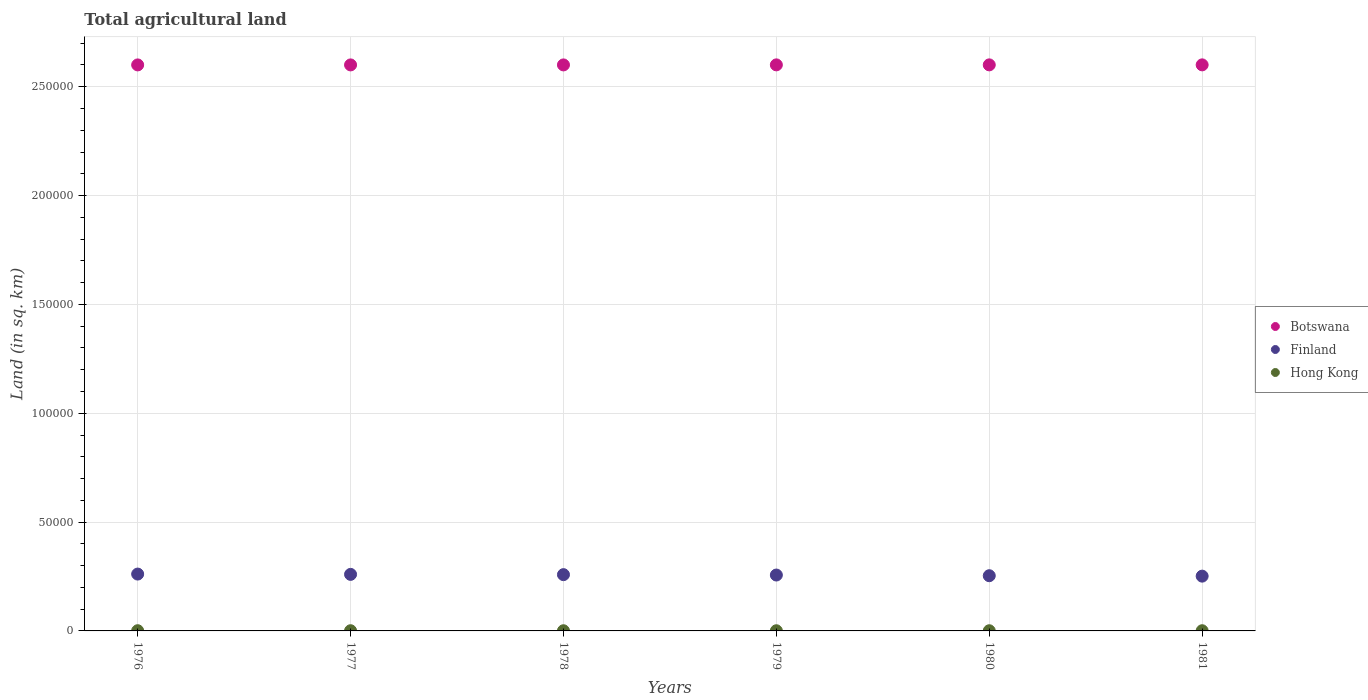How many different coloured dotlines are there?
Offer a terse response. 3. Is the number of dotlines equal to the number of legend labels?
Your answer should be compact. Yes. What is the total agricultural land in Botswana in 1978?
Provide a short and direct response. 2.60e+05. Across all years, what is the maximum total agricultural land in Botswana?
Your answer should be compact. 2.60e+05. Across all years, what is the minimum total agricultural land in Finland?
Your answer should be very brief. 2.52e+04. In which year was the total agricultural land in Hong Kong maximum?
Give a very brief answer. 1976. In which year was the total agricultural land in Hong Kong minimum?
Your answer should be very brief. 1978. What is the total total agricultural land in Finland in the graph?
Your answer should be very brief. 1.54e+05. What is the difference between the total agricultural land in Botswana in 1976 and that in 1979?
Offer a terse response. -20. What is the difference between the total agricultural land in Hong Kong in 1978 and the total agricultural land in Finland in 1980?
Offer a very short reply. -2.53e+04. What is the average total agricultural land in Finland per year?
Your response must be concise. 2.57e+04. In the year 1980, what is the difference between the total agricultural land in Finland and total agricultural land in Botswana?
Your response must be concise. -2.35e+05. What is the ratio of the total agricultural land in Finland in 1976 to that in 1981?
Your response must be concise. 1.04. Is the difference between the total agricultural land in Finland in 1980 and 1981 greater than the difference between the total agricultural land in Botswana in 1980 and 1981?
Offer a terse response. Yes. What is the difference between the highest and the second highest total agricultural land in Hong Kong?
Ensure brevity in your answer.  10. What is the difference between the highest and the lowest total agricultural land in Finland?
Give a very brief answer. 952. In how many years, is the total agricultural land in Botswana greater than the average total agricultural land in Botswana taken over all years?
Provide a succinct answer. 3. Does the total agricultural land in Hong Kong monotonically increase over the years?
Your answer should be compact. No. What is the difference between two consecutive major ticks on the Y-axis?
Ensure brevity in your answer.  5.00e+04. Does the graph contain any zero values?
Your response must be concise. No. Where does the legend appear in the graph?
Your answer should be compact. Center right. What is the title of the graph?
Make the answer very short. Total agricultural land. What is the label or title of the X-axis?
Give a very brief answer. Years. What is the label or title of the Y-axis?
Make the answer very short. Land (in sq. km). What is the Land (in sq. km) of Botswana in 1976?
Make the answer very short. 2.60e+05. What is the Land (in sq. km) of Finland in 1976?
Provide a short and direct response. 2.61e+04. What is the Land (in sq. km) in Hong Kong in 1976?
Your answer should be very brief. 100. What is the Land (in sq. km) of Botswana in 1977?
Provide a short and direct response. 2.60e+05. What is the Land (in sq. km) of Finland in 1977?
Offer a terse response. 2.60e+04. What is the Land (in sq. km) in Botswana in 1978?
Provide a short and direct response. 2.60e+05. What is the Land (in sq. km) in Finland in 1978?
Your answer should be compact. 2.59e+04. What is the Land (in sq. km) in Hong Kong in 1978?
Provide a succinct answer. 80. What is the Land (in sq. km) of Botswana in 1979?
Give a very brief answer. 2.60e+05. What is the Land (in sq. km) of Finland in 1979?
Keep it short and to the point. 2.57e+04. What is the Land (in sq. km) of Botswana in 1980?
Your answer should be very brief. 2.60e+05. What is the Land (in sq. km) in Finland in 1980?
Your answer should be compact. 2.54e+04. What is the Land (in sq. km) of Hong Kong in 1980?
Offer a very short reply. 80. What is the Land (in sq. km) in Botswana in 1981?
Give a very brief answer. 2.60e+05. What is the Land (in sq. km) in Finland in 1981?
Give a very brief answer. 2.52e+04. What is the Land (in sq. km) of Hong Kong in 1981?
Offer a very short reply. 90. Across all years, what is the maximum Land (in sq. km) in Botswana?
Give a very brief answer. 2.60e+05. Across all years, what is the maximum Land (in sq. km) of Finland?
Your response must be concise. 2.61e+04. Across all years, what is the maximum Land (in sq. km) in Hong Kong?
Your response must be concise. 100. Across all years, what is the minimum Land (in sq. km) of Botswana?
Ensure brevity in your answer.  2.60e+05. Across all years, what is the minimum Land (in sq. km) of Finland?
Keep it short and to the point. 2.52e+04. Across all years, what is the minimum Land (in sq. km) of Hong Kong?
Keep it short and to the point. 80. What is the total Land (in sq. km) in Botswana in the graph?
Offer a terse response. 1.56e+06. What is the total Land (in sq. km) of Finland in the graph?
Make the answer very short. 1.54e+05. What is the total Land (in sq. km) in Hong Kong in the graph?
Your answer should be compact. 520. What is the difference between the Land (in sq. km) of Finland in 1976 and that in 1977?
Ensure brevity in your answer.  143. What is the difference between the Land (in sq. km) of Hong Kong in 1976 and that in 1977?
Make the answer very short. 10. What is the difference between the Land (in sq. km) in Finland in 1976 and that in 1978?
Provide a short and direct response. 268. What is the difference between the Land (in sq. km) of Hong Kong in 1976 and that in 1978?
Your answer should be very brief. 20. What is the difference between the Land (in sq. km) of Finland in 1976 and that in 1979?
Ensure brevity in your answer.  444. What is the difference between the Land (in sq. km) of Finland in 1976 and that in 1980?
Your answer should be very brief. 759. What is the difference between the Land (in sq. km) of Finland in 1976 and that in 1981?
Give a very brief answer. 952. What is the difference between the Land (in sq. km) of Finland in 1977 and that in 1978?
Make the answer very short. 125. What is the difference between the Land (in sq. km) of Hong Kong in 1977 and that in 1978?
Your response must be concise. 10. What is the difference between the Land (in sq. km) of Botswana in 1977 and that in 1979?
Your response must be concise. -20. What is the difference between the Land (in sq. km) of Finland in 1977 and that in 1979?
Offer a very short reply. 301. What is the difference between the Land (in sq. km) of Botswana in 1977 and that in 1980?
Keep it short and to the point. -20. What is the difference between the Land (in sq. km) of Finland in 1977 and that in 1980?
Your response must be concise. 616. What is the difference between the Land (in sq. km) in Botswana in 1977 and that in 1981?
Give a very brief answer. -20. What is the difference between the Land (in sq. km) in Finland in 1977 and that in 1981?
Offer a very short reply. 809. What is the difference between the Land (in sq. km) in Hong Kong in 1977 and that in 1981?
Offer a terse response. 0. What is the difference between the Land (in sq. km) of Finland in 1978 and that in 1979?
Provide a succinct answer. 176. What is the difference between the Land (in sq. km) in Botswana in 1978 and that in 1980?
Offer a terse response. -20. What is the difference between the Land (in sq. km) in Finland in 1978 and that in 1980?
Your answer should be compact. 491. What is the difference between the Land (in sq. km) in Finland in 1978 and that in 1981?
Your response must be concise. 684. What is the difference between the Land (in sq. km) of Hong Kong in 1978 and that in 1981?
Give a very brief answer. -10. What is the difference between the Land (in sq. km) in Botswana in 1979 and that in 1980?
Provide a short and direct response. 0. What is the difference between the Land (in sq. km) of Finland in 1979 and that in 1980?
Your response must be concise. 315. What is the difference between the Land (in sq. km) of Botswana in 1979 and that in 1981?
Keep it short and to the point. 0. What is the difference between the Land (in sq. km) of Finland in 1979 and that in 1981?
Give a very brief answer. 508. What is the difference between the Land (in sq. km) in Botswana in 1980 and that in 1981?
Offer a terse response. 0. What is the difference between the Land (in sq. km) of Finland in 1980 and that in 1981?
Offer a very short reply. 193. What is the difference between the Land (in sq. km) in Botswana in 1976 and the Land (in sq. km) in Finland in 1977?
Offer a very short reply. 2.34e+05. What is the difference between the Land (in sq. km) in Botswana in 1976 and the Land (in sq. km) in Hong Kong in 1977?
Make the answer very short. 2.60e+05. What is the difference between the Land (in sq. km) of Finland in 1976 and the Land (in sq. km) of Hong Kong in 1977?
Provide a short and direct response. 2.60e+04. What is the difference between the Land (in sq. km) of Botswana in 1976 and the Land (in sq. km) of Finland in 1978?
Offer a very short reply. 2.34e+05. What is the difference between the Land (in sq. km) of Botswana in 1976 and the Land (in sq. km) of Hong Kong in 1978?
Give a very brief answer. 2.60e+05. What is the difference between the Land (in sq. km) of Finland in 1976 and the Land (in sq. km) of Hong Kong in 1978?
Your answer should be compact. 2.60e+04. What is the difference between the Land (in sq. km) in Botswana in 1976 and the Land (in sq. km) in Finland in 1979?
Your answer should be very brief. 2.34e+05. What is the difference between the Land (in sq. km) of Botswana in 1976 and the Land (in sq. km) of Hong Kong in 1979?
Ensure brevity in your answer.  2.60e+05. What is the difference between the Land (in sq. km) of Finland in 1976 and the Land (in sq. km) of Hong Kong in 1979?
Your answer should be very brief. 2.60e+04. What is the difference between the Land (in sq. km) in Botswana in 1976 and the Land (in sq. km) in Finland in 1980?
Make the answer very short. 2.35e+05. What is the difference between the Land (in sq. km) in Botswana in 1976 and the Land (in sq. km) in Hong Kong in 1980?
Give a very brief answer. 2.60e+05. What is the difference between the Land (in sq. km) in Finland in 1976 and the Land (in sq. km) in Hong Kong in 1980?
Your answer should be very brief. 2.60e+04. What is the difference between the Land (in sq. km) of Botswana in 1976 and the Land (in sq. km) of Finland in 1981?
Provide a succinct answer. 2.35e+05. What is the difference between the Land (in sq. km) of Botswana in 1976 and the Land (in sq. km) of Hong Kong in 1981?
Your answer should be compact. 2.60e+05. What is the difference between the Land (in sq. km) in Finland in 1976 and the Land (in sq. km) in Hong Kong in 1981?
Your answer should be compact. 2.60e+04. What is the difference between the Land (in sq. km) in Botswana in 1977 and the Land (in sq. km) in Finland in 1978?
Offer a terse response. 2.34e+05. What is the difference between the Land (in sq. km) in Botswana in 1977 and the Land (in sq. km) in Hong Kong in 1978?
Your answer should be very brief. 2.60e+05. What is the difference between the Land (in sq. km) of Finland in 1977 and the Land (in sq. km) of Hong Kong in 1978?
Offer a terse response. 2.59e+04. What is the difference between the Land (in sq. km) of Botswana in 1977 and the Land (in sq. km) of Finland in 1979?
Provide a short and direct response. 2.34e+05. What is the difference between the Land (in sq. km) in Botswana in 1977 and the Land (in sq. km) in Hong Kong in 1979?
Your answer should be very brief. 2.60e+05. What is the difference between the Land (in sq. km) in Finland in 1977 and the Land (in sq. km) in Hong Kong in 1979?
Provide a succinct answer. 2.59e+04. What is the difference between the Land (in sq. km) of Botswana in 1977 and the Land (in sq. km) of Finland in 1980?
Ensure brevity in your answer.  2.35e+05. What is the difference between the Land (in sq. km) in Botswana in 1977 and the Land (in sq. km) in Hong Kong in 1980?
Offer a very short reply. 2.60e+05. What is the difference between the Land (in sq. km) in Finland in 1977 and the Land (in sq. km) in Hong Kong in 1980?
Give a very brief answer. 2.59e+04. What is the difference between the Land (in sq. km) of Botswana in 1977 and the Land (in sq. km) of Finland in 1981?
Your response must be concise. 2.35e+05. What is the difference between the Land (in sq. km) of Botswana in 1977 and the Land (in sq. km) of Hong Kong in 1981?
Give a very brief answer. 2.60e+05. What is the difference between the Land (in sq. km) of Finland in 1977 and the Land (in sq. km) of Hong Kong in 1981?
Provide a succinct answer. 2.59e+04. What is the difference between the Land (in sq. km) of Botswana in 1978 and the Land (in sq. km) of Finland in 1979?
Keep it short and to the point. 2.34e+05. What is the difference between the Land (in sq. km) of Botswana in 1978 and the Land (in sq. km) of Hong Kong in 1979?
Make the answer very short. 2.60e+05. What is the difference between the Land (in sq. km) of Finland in 1978 and the Land (in sq. km) of Hong Kong in 1979?
Provide a short and direct response. 2.58e+04. What is the difference between the Land (in sq. km) of Botswana in 1978 and the Land (in sq. km) of Finland in 1980?
Offer a very short reply. 2.35e+05. What is the difference between the Land (in sq. km) in Botswana in 1978 and the Land (in sq. km) in Hong Kong in 1980?
Provide a short and direct response. 2.60e+05. What is the difference between the Land (in sq. km) of Finland in 1978 and the Land (in sq. km) of Hong Kong in 1980?
Provide a short and direct response. 2.58e+04. What is the difference between the Land (in sq. km) in Botswana in 1978 and the Land (in sq. km) in Finland in 1981?
Make the answer very short. 2.35e+05. What is the difference between the Land (in sq. km) of Botswana in 1978 and the Land (in sq. km) of Hong Kong in 1981?
Provide a succinct answer. 2.60e+05. What is the difference between the Land (in sq. km) of Finland in 1978 and the Land (in sq. km) of Hong Kong in 1981?
Your answer should be very brief. 2.58e+04. What is the difference between the Land (in sq. km) in Botswana in 1979 and the Land (in sq. km) in Finland in 1980?
Provide a succinct answer. 2.35e+05. What is the difference between the Land (in sq. km) of Botswana in 1979 and the Land (in sq. km) of Hong Kong in 1980?
Give a very brief answer. 2.60e+05. What is the difference between the Land (in sq. km) in Finland in 1979 and the Land (in sq. km) in Hong Kong in 1980?
Make the answer very short. 2.56e+04. What is the difference between the Land (in sq. km) of Botswana in 1979 and the Land (in sq. km) of Finland in 1981?
Your response must be concise. 2.35e+05. What is the difference between the Land (in sq. km) in Botswana in 1979 and the Land (in sq. km) in Hong Kong in 1981?
Provide a short and direct response. 2.60e+05. What is the difference between the Land (in sq. km) in Finland in 1979 and the Land (in sq. km) in Hong Kong in 1981?
Keep it short and to the point. 2.56e+04. What is the difference between the Land (in sq. km) of Botswana in 1980 and the Land (in sq. km) of Finland in 1981?
Offer a very short reply. 2.35e+05. What is the difference between the Land (in sq. km) in Botswana in 1980 and the Land (in sq. km) in Hong Kong in 1981?
Offer a very short reply. 2.60e+05. What is the difference between the Land (in sq. km) of Finland in 1980 and the Land (in sq. km) of Hong Kong in 1981?
Your response must be concise. 2.53e+04. What is the average Land (in sq. km) of Botswana per year?
Offer a terse response. 2.60e+05. What is the average Land (in sq. km) of Finland per year?
Provide a succinct answer. 2.57e+04. What is the average Land (in sq. km) of Hong Kong per year?
Offer a terse response. 86.67. In the year 1976, what is the difference between the Land (in sq. km) of Botswana and Land (in sq. km) of Finland?
Make the answer very short. 2.34e+05. In the year 1976, what is the difference between the Land (in sq. km) of Botswana and Land (in sq. km) of Hong Kong?
Your answer should be compact. 2.60e+05. In the year 1976, what is the difference between the Land (in sq. km) in Finland and Land (in sq. km) in Hong Kong?
Keep it short and to the point. 2.60e+04. In the year 1977, what is the difference between the Land (in sq. km) of Botswana and Land (in sq. km) of Finland?
Provide a succinct answer. 2.34e+05. In the year 1977, what is the difference between the Land (in sq. km) of Botswana and Land (in sq. km) of Hong Kong?
Make the answer very short. 2.60e+05. In the year 1977, what is the difference between the Land (in sq. km) of Finland and Land (in sq. km) of Hong Kong?
Provide a short and direct response. 2.59e+04. In the year 1978, what is the difference between the Land (in sq. km) in Botswana and Land (in sq. km) in Finland?
Ensure brevity in your answer.  2.34e+05. In the year 1978, what is the difference between the Land (in sq. km) in Botswana and Land (in sq. km) in Hong Kong?
Your answer should be very brief. 2.60e+05. In the year 1978, what is the difference between the Land (in sq. km) of Finland and Land (in sq. km) of Hong Kong?
Your answer should be very brief. 2.58e+04. In the year 1979, what is the difference between the Land (in sq. km) in Botswana and Land (in sq. km) in Finland?
Keep it short and to the point. 2.34e+05. In the year 1979, what is the difference between the Land (in sq. km) in Botswana and Land (in sq. km) in Hong Kong?
Keep it short and to the point. 2.60e+05. In the year 1979, what is the difference between the Land (in sq. km) in Finland and Land (in sq. km) in Hong Kong?
Provide a short and direct response. 2.56e+04. In the year 1980, what is the difference between the Land (in sq. km) of Botswana and Land (in sq. km) of Finland?
Your answer should be very brief. 2.35e+05. In the year 1980, what is the difference between the Land (in sq. km) of Botswana and Land (in sq. km) of Hong Kong?
Give a very brief answer. 2.60e+05. In the year 1980, what is the difference between the Land (in sq. km) in Finland and Land (in sq. km) in Hong Kong?
Provide a short and direct response. 2.53e+04. In the year 1981, what is the difference between the Land (in sq. km) of Botswana and Land (in sq. km) of Finland?
Your answer should be very brief. 2.35e+05. In the year 1981, what is the difference between the Land (in sq. km) of Botswana and Land (in sq. km) of Hong Kong?
Your answer should be very brief. 2.60e+05. In the year 1981, what is the difference between the Land (in sq. km) of Finland and Land (in sq. km) of Hong Kong?
Give a very brief answer. 2.51e+04. What is the ratio of the Land (in sq. km) of Botswana in 1976 to that in 1977?
Offer a very short reply. 1. What is the ratio of the Land (in sq. km) in Finland in 1976 to that in 1977?
Offer a terse response. 1.01. What is the ratio of the Land (in sq. km) in Hong Kong in 1976 to that in 1977?
Your answer should be very brief. 1.11. What is the ratio of the Land (in sq. km) of Botswana in 1976 to that in 1978?
Your answer should be compact. 1. What is the ratio of the Land (in sq. km) in Finland in 1976 to that in 1978?
Your response must be concise. 1.01. What is the ratio of the Land (in sq. km) of Hong Kong in 1976 to that in 1978?
Your response must be concise. 1.25. What is the ratio of the Land (in sq. km) of Finland in 1976 to that in 1979?
Make the answer very short. 1.02. What is the ratio of the Land (in sq. km) of Hong Kong in 1976 to that in 1979?
Provide a succinct answer. 1.25. What is the ratio of the Land (in sq. km) of Botswana in 1976 to that in 1980?
Keep it short and to the point. 1. What is the ratio of the Land (in sq. km) of Finland in 1976 to that in 1980?
Your response must be concise. 1.03. What is the ratio of the Land (in sq. km) of Hong Kong in 1976 to that in 1980?
Provide a short and direct response. 1.25. What is the ratio of the Land (in sq. km) in Botswana in 1976 to that in 1981?
Offer a terse response. 1. What is the ratio of the Land (in sq. km) of Finland in 1976 to that in 1981?
Provide a succinct answer. 1.04. What is the ratio of the Land (in sq. km) in Finland in 1977 to that in 1978?
Make the answer very short. 1. What is the ratio of the Land (in sq. km) in Finland in 1977 to that in 1979?
Offer a terse response. 1.01. What is the ratio of the Land (in sq. km) in Botswana in 1977 to that in 1980?
Your answer should be compact. 1. What is the ratio of the Land (in sq. km) in Finland in 1977 to that in 1980?
Make the answer very short. 1.02. What is the ratio of the Land (in sq. km) in Hong Kong in 1977 to that in 1980?
Your answer should be compact. 1.12. What is the ratio of the Land (in sq. km) of Botswana in 1977 to that in 1981?
Offer a very short reply. 1. What is the ratio of the Land (in sq. km) of Finland in 1977 to that in 1981?
Your answer should be compact. 1.03. What is the ratio of the Land (in sq. km) of Botswana in 1978 to that in 1979?
Offer a terse response. 1. What is the ratio of the Land (in sq. km) in Botswana in 1978 to that in 1980?
Offer a terse response. 1. What is the ratio of the Land (in sq. km) in Finland in 1978 to that in 1980?
Your answer should be very brief. 1.02. What is the ratio of the Land (in sq. km) of Hong Kong in 1978 to that in 1980?
Give a very brief answer. 1. What is the ratio of the Land (in sq. km) of Botswana in 1978 to that in 1981?
Provide a succinct answer. 1. What is the ratio of the Land (in sq. km) of Finland in 1978 to that in 1981?
Provide a succinct answer. 1.03. What is the ratio of the Land (in sq. km) of Finland in 1979 to that in 1980?
Offer a very short reply. 1.01. What is the ratio of the Land (in sq. km) in Finland in 1979 to that in 1981?
Your response must be concise. 1.02. What is the ratio of the Land (in sq. km) of Finland in 1980 to that in 1981?
Your answer should be compact. 1.01. What is the ratio of the Land (in sq. km) in Hong Kong in 1980 to that in 1981?
Offer a terse response. 0.89. What is the difference between the highest and the second highest Land (in sq. km) in Botswana?
Your answer should be very brief. 0. What is the difference between the highest and the second highest Land (in sq. km) of Finland?
Your response must be concise. 143. What is the difference between the highest and the lowest Land (in sq. km) in Finland?
Give a very brief answer. 952. What is the difference between the highest and the lowest Land (in sq. km) of Hong Kong?
Offer a very short reply. 20. 